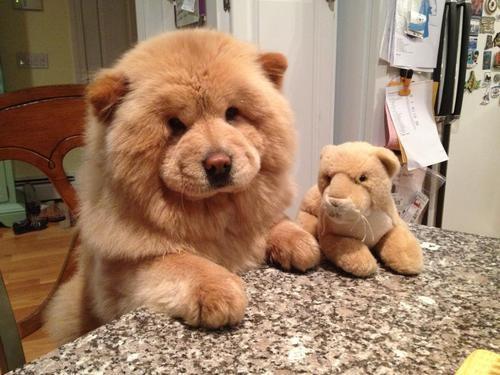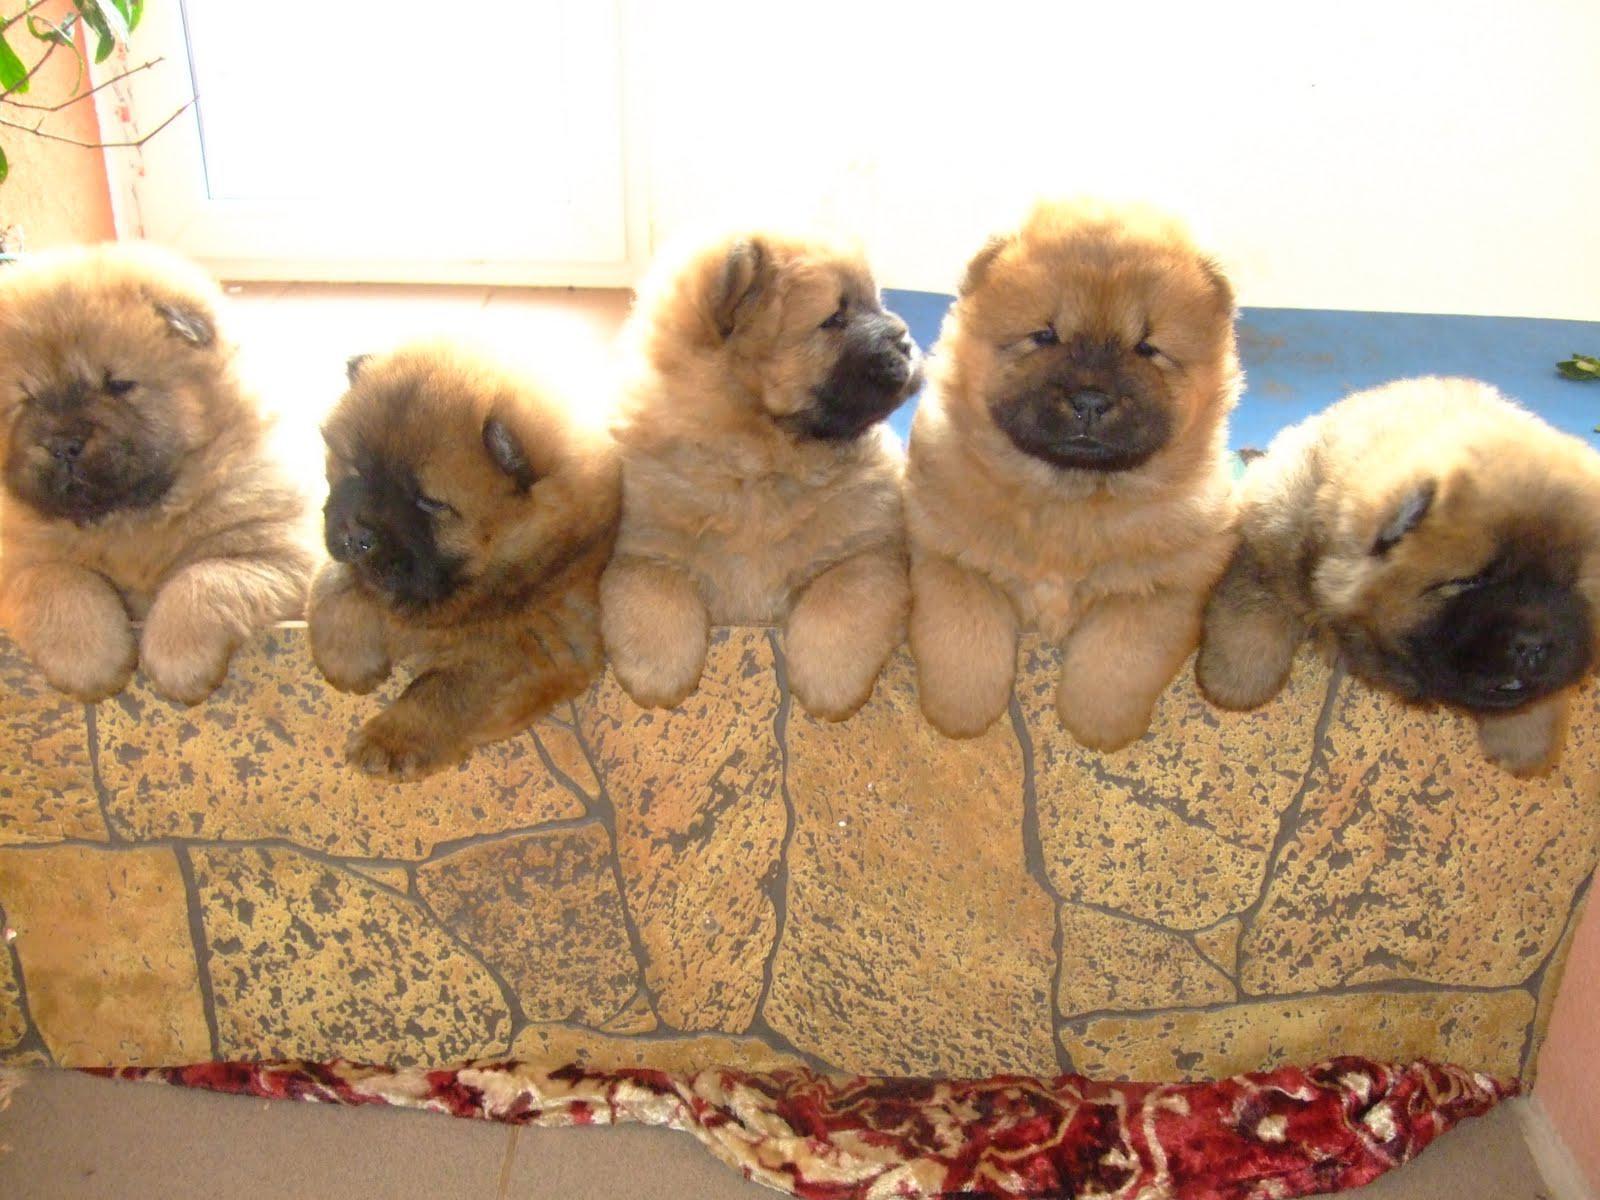The first image is the image on the left, the second image is the image on the right. Assess this claim about the two images: "There is a dog with a stuffed animal in the image on the left.". Correct or not? Answer yes or no. Yes. 